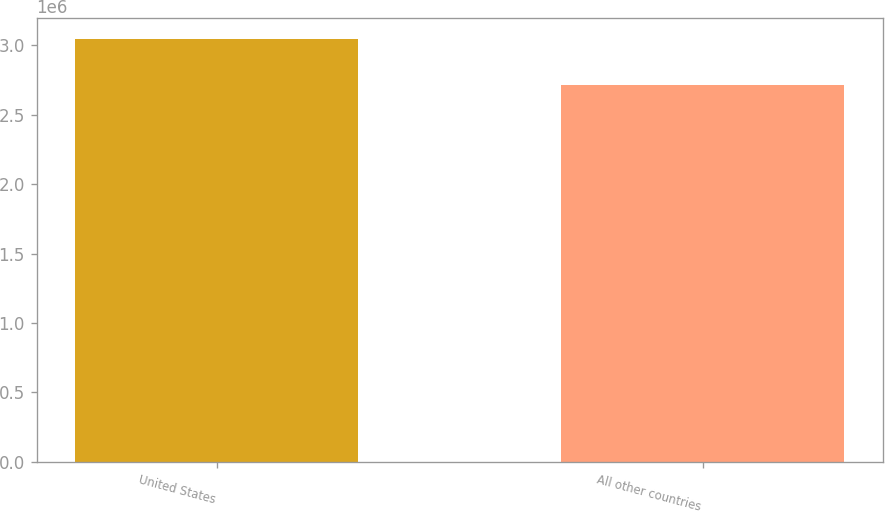Convert chart to OTSL. <chart><loc_0><loc_0><loc_500><loc_500><bar_chart><fcel>United States<fcel>All other countries<nl><fcel>3.04652e+06<fcel>2.71696e+06<nl></chart> 